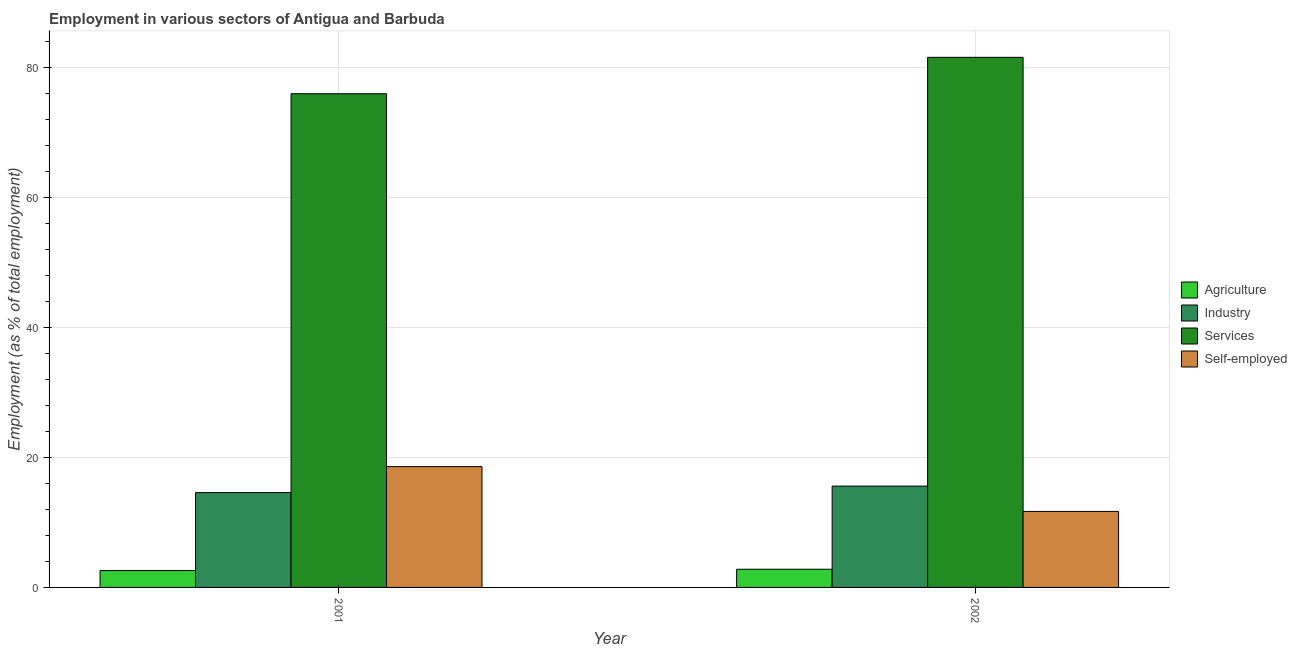Are the number of bars on each tick of the X-axis equal?
Make the answer very short. Yes. How many bars are there on the 2nd tick from the left?
Make the answer very short. 4. In how many cases, is the number of bars for a given year not equal to the number of legend labels?
Your answer should be compact. 0. Across all years, what is the maximum percentage of workers in agriculture?
Provide a short and direct response. 2.8. Across all years, what is the minimum percentage of self employed workers?
Your response must be concise. 11.7. In which year was the percentage of workers in industry maximum?
Your answer should be compact. 2002. In which year was the percentage of workers in industry minimum?
Provide a short and direct response. 2001. What is the total percentage of workers in industry in the graph?
Keep it short and to the point. 30.2. What is the difference between the percentage of self employed workers in 2001 and that in 2002?
Provide a succinct answer. 6.9. What is the average percentage of workers in agriculture per year?
Your response must be concise. 2.7. In the year 2001, what is the difference between the percentage of self employed workers and percentage of workers in services?
Offer a very short reply. 0. What is the ratio of the percentage of workers in agriculture in 2001 to that in 2002?
Keep it short and to the point. 0.93. Is the percentage of workers in agriculture in 2001 less than that in 2002?
Your answer should be very brief. Yes. What does the 4th bar from the left in 2001 represents?
Keep it short and to the point. Self-employed. What does the 1st bar from the right in 2001 represents?
Keep it short and to the point. Self-employed. How many bars are there?
Give a very brief answer. 8. How many years are there in the graph?
Keep it short and to the point. 2. Are the values on the major ticks of Y-axis written in scientific E-notation?
Offer a terse response. No. Does the graph contain any zero values?
Your answer should be very brief. No. Does the graph contain grids?
Ensure brevity in your answer.  Yes. How many legend labels are there?
Offer a terse response. 4. How are the legend labels stacked?
Give a very brief answer. Vertical. What is the title of the graph?
Your answer should be very brief. Employment in various sectors of Antigua and Barbuda. Does "International Development Association" appear as one of the legend labels in the graph?
Your response must be concise. No. What is the label or title of the X-axis?
Ensure brevity in your answer.  Year. What is the label or title of the Y-axis?
Offer a terse response. Employment (as % of total employment). What is the Employment (as % of total employment) in Agriculture in 2001?
Keep it short and to the point. 2.6. What is the Employment (as % of total employment) of Industry in 2001?
Give a very brief answer. 14.6. What is the Employment (as % of total employment) of Self-employed in 2001?
Keep it short and to the point. 18.6. What is the Employment (as % of total employment) in Agriculture in 2002?
Ensure brevity in your answer.  2.8. What is the Employment (as % of total employment) of Industry in 2002?
Your response must be concise. 15.6. What is the Employment (as % of total employment) of Services in 2002?
Give a very brief answer. 81.6. What is the Employment (as % of total employment) of Self-employed in 2002?
Your answer should be compact. 11.7. Across all years, what is the maximum Employment (as % of total employment) in Agriculture?
Keep it short and to the point. 2.8. Across all years, what is the maximum Employment (as % of total employment) in Industry?
Make the answer very short. 15.6. Across all years, what is the maximum Employment (as % of total employment) in Services?
Ensure brevity in your answer.  81.6. Across all years, what is the maximum Employment (as % of total employment) of Self-employed?
Offer a terse response. 18.6. Across all years, what is the minimum Employment (as % of total employment) in Agriculture?
Your answer should be very brief. 2.6. Across all years, what is the minimum Employment (as % of total employment) of Industry?
Your answer should be compact. 14.6. Across all years, what is the minimum Employment (as % of total employment) of Self-employed?
Your answer should be compact. 11.7. What is the total Employment (as % of total employment) of Agriculture in the graph?
Offer a very short reply. 5.4. What is the total Employment (as % of total employment) in Industry in the graph?
Your answer should be compact. 30.2. What is the total Employment (as % of total employment) of Services in the graph?
Offer a very short reply. 157.6. What is the total Employment (as % of total employment) of Self-employed in the graph?
Ensure brevity in your answer.  30.3. What is the difference between the Employment (as % of total employment) of Agriculture in 2001 and that in 2002?
Offer a very short reply. -0.2. What is the difference between the Employment (as % of total employment) of Services in 2001 and that in 2002?
Your answer should be compact. -5.6. What is the difference between the Employment (as % of total employment) of Agriculture in 2001 and the Employment (as % of total employment) of Services in 2002?
Your response must be concise. -79. What is the difference between the Employment (as % of total employment) of Industry in 2001 and the Employment (as % of total employment) of Services in 2002?
Keep it short and to the point. -67. What is the difference between the Employment (as % of total employment) in Industry in 2001 and the Employment (as % of total employment) in Self-employed in 2002?
Your answer should be compact. 2.9. What is the difference between the Employment (as % of total employment) in Services in 2001 and the Employment (as % of total employment) in Self-employed in 2002?
Ensure brevity in your answer.  64.3. What is the average Employment (as % of total employment) of Agriculture per year?
Offer a terse response. 2.7. What is the average Employment (as % of total employment) in Services per year?
Your response must be concise. 78.8. What is the average Employment (as % of total employment) in Self-employed per year?
Your response must be concise. 15.15. In the year 2001, what is the difference between the Employment (as % of total employment) in Agriculture and Employment (as % of total employment) in Services?
Your answer should be compact. -73.4. In the year 2001, what is the difference between the Employment (as % of total employment) in Industry and Employment (as % of total employment) in Services?
Provide a short and direct response. -61.4. In the year 2001, what is the difference between the Employment (as % of total employment) of Industry and Employment (as % of total employment) of Self-employed?
Make the answer very short. -4. In the year 2001, what is the difference between the Employment (as % of total employment) of Services and Employment (as % of total employment) of Self-employed?
Provide a succinct answer. 57.4. In the year 2002, what is the difference between the Employment (as % of total employment) in Agriculture and Employment (as % of total employment) in Industry?
Give a very brief answer. -12.8. In the year 2002, what is the difference between the Employment (as % of total employment) in Agriculture and Employment (as % of total employment) in Services?
Provide a short and direct response. -78.8. In the year 2002, what is the difference between the Employment (as % of total employment) in Industry and Employment (as % of total employment) in Services?
Provide a short and direct response. -66. In the year 2002, what is the difference between the Employment (as % of total employment) in Industry and Employment (as % of total employment) in Self-employed?
Provide a succinct answer. 3.9. In the year 2002, what is the difference between the Employment (as % of total employment) of Services and Employment (as % of total employment) of Self-employed?
Your response must be concise. 69.9. What is the ratio of the Employment (as % of total employment) of Industry in 2001 to that in 2002?
Give a very brief answer. 0.94. What is the ratio of the Employment (as % of total employment) in Services in 2001 to that in 2002?
Offer a very short reply. 0.93. What is the ratio of the Employment (as % of total employment) of Self-employed in 2001 to that in 2002?
Your response must be concise. 1.59. What is the difference between the highest and the second highest Employment (as % of total employment) of Agriculture?
Ensure brevity in your answer.  0.2. What is the difference between the highest and the second highest Employment (as % of total employment) of Services?
Give a very brief answer. 5.6. What is the difference between the highest and the lowest Employment (as % of total employment) of Agriculture?
Provide a short and direct response. 0.2. What is the difference between the highest and the lowest Employment (as % of total employment) of Industry?
Your answer should be compact. 1. What is the difference between the highest and the lowest Employment (as % of total employment) in Services?
Provide a succinct answer. 5.6. 